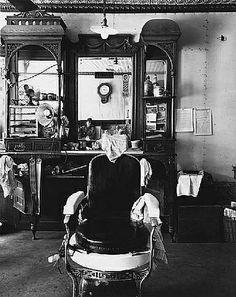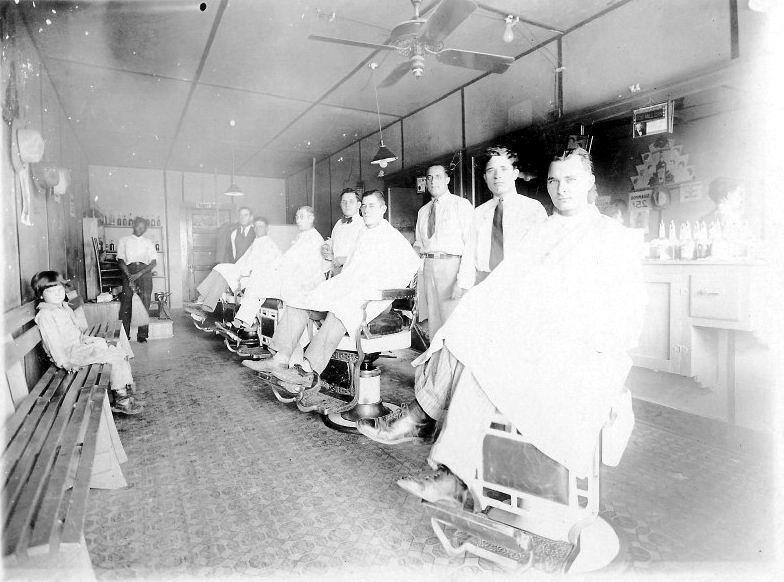The first image is the image on the left, the second image is the image on the right. Considering the images on both sides, is "Five barbers are working with customers seated in chairs." valid? Answer yes or no. No. The first image is the image on the left, the second image is the image on the right. Evaluate the accuracy of this statement regarding the images: "There are exactly two men sitting in barbers chairs in the image on the right.". Is it true? Answer yes or no. No. 